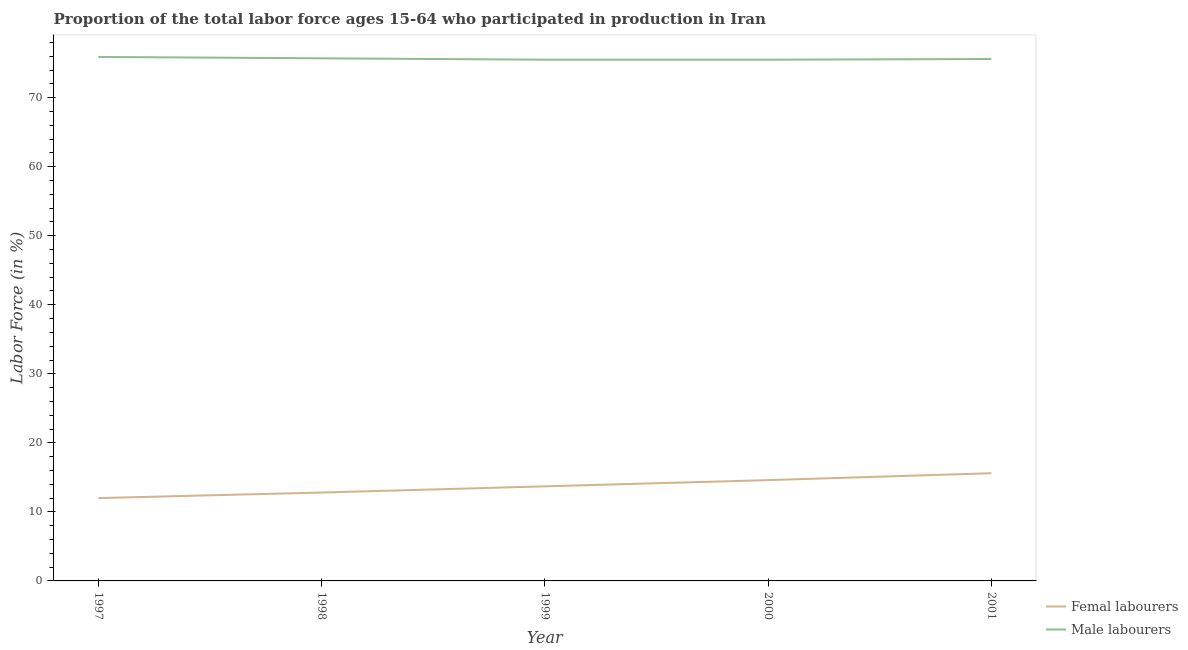How many different coloured lines are there?
Your answer should be compact. 2. What is the percentage of female labor force in 2001?
Keep it short and to the point. 15.6. Across all years, what is the maximum percentage of male labour force?
Your response must be concise. 75.9. Across all years, what is the minimum percentage of female labor force?
Give a very brief answer. 12. In which year was the percentage of male labour force minimum?
Provide a short and direct response. 1999. What is the total percentage of female labor force in the graph?
Make the answer very short. 68.7. What is the difference between the percentage of female labor force in 1998 and that in 2001?
Keep it short and to the point. -2.8. What is the difference between the percentage of male labour force in 1999 and the percentage of female labor force in 1998?
Your answer should be compact. 62.7. What is the average percentage of female labor force per year?
Your answer should be very brief. 13.74. In the year 2001, what is the difference between the percentage of female labor force and percentage of male labour force?
Provide a short and direct response. -60. What is the ratio of the percentage of male labour force in 1997 to that in 2000?
Provide a short and direct response. 1.01. What is the difference between the highest and the lowest percentage of male labour force?
Provide a short and direct response. 0.4. In how many years, is the percentage of female labor force greater than the average percentage of female labor force taken over all years?
Offer a terse response. 2. Is the sum of the percentage of female labor force in 1997 and 1998 greater than the maximum percentage of male labour force across all years?
Offer a very short reply. No. Does the percentage of female labor force monotonically increase over the years?
Provide a short and direct response. Yes. Is the percentage of female labor force strictly greater than the percentage of male labour force over the years?
Offer a terse response. No. How many lines are there?
Offer a very short reply. 2. How many legend labels are there?
Ensure brevity in your answer.  2. What is the title of the graph?
Provide a short and direct response. Proportion of the total labor force ages 15-64 who participated in production in Iran. What is the label or title of the Y-axis?
Offer a very short reply. Labor Force (in %). What is the Labor Force (in %) in Male labourers in 1997?
Ensure brevity in your answer.  75.9. What is the Labor Force (in %) in Femal labourers in 1998?
Your answer should be compact. 12.8. What is the Labor Force (in %) of Male labourers in 1998?
Offer a very short reply. 75.7. What is the Labor Force (in %) of Femal labourers in 1999?
Keep it short and to the point. 13.7. What is the Labor Force (in %) of Male labourers in 1999?
Offer a terse response. 75.5. What is the Labor Force (in %) of Femal labourers in 2000?
Your answer should be compact. 14.6. What is the Labor Force (in %) in Male labourers in 2000?
Provide a short and direct response. 75.5. What is the Labor Force (in %) of Femal labourers in 2001?
Keep it short and to the point. 15.6. What is the Labor Force (in %) in Male labourers in 2001?
Offer a terse response. 75.6. Across all years, what is the maximum Labor Force (in %) of Femal labourers?
Provide a short and direct response. 15.6. Across all years, what is the maximum Labor Force (in %) of Male labourers?
Make the answer very short. 75.9. Across all years, what is the minimum Labor Force (in %) of Femal labourers?
Make the answer very short. 12. Across all years, what is the minimum Labor Force (in %) of Male labourers?
Provide a succinct answer. 75.5. What is the total Labor Force (in %) in Femal labourers in the graph?
Keep it short and to the point. 68.7. What is the total Labor Force (in %) of Male labourers in the graph?
Your answer should be very brief. 378.2. What is the difference between the Labor Force (in %) in Male labourers in 1997 and that in 1998?
Your response must be concise. 0.2. What is the difference between the Labor Force (in %) of Femal labourers in 1997 and that in 1999?
Offer a terse response. -1.7. What is the difference between the Labor Force (in %) of Male labourers in 1997 and that in 2001?
Your response must be concise. 0.3. What is the difference between the Labor Force (in %) in Femal labourers in 1998 and that in 2001?
Keep it short and to the point. -2.8. What is the difference between the Labor Force (in %) in Male labourers in 1998 and that in 2001?
Give a very brief answer. 0.1. What is the difference between the Labor Force (in %) of Femal labourers in 1999 and that in 2000?
Keep it short and to the point. -0.9. What is the difference between the Labor Force (in %) of Femal labourers in 1997 and the Labor Force (in %) of Male labourers in 1998?
Give a very brief answer. -63.7. What is the difference between the Labor Force (in %) of Femal labourers in 1997 and the Labor Force (in %) of Male labourers in 1999?
Your answer should be very brief. -63.5. What is the difference between the Labor Force (in %) in Femal labourers in 1997 and the Labor Force (in %) in Male labourers in 2000?
Offer a terse response. -63.5. What is the difference between the Labor Force (in %) of Femal labourers in 1997 and the Labor Force (in %) of Male labourers in 2001?
Provide a succinct answer. -63.6. What is the difference between the Labor Force (in %) of Femal labourers in 1998 and the Labor Force (in %) of Male labourers in 1999?
Keep it short and to the point. -62.7. What is the difference between the Labor Force (in %) in Femal labourers in 1998 and the Labor Force (in %) in Male labourers in 2000?
Your answer should be compact. -62.7. What is the difference between the Labor Force (in %) of Femal labourers in 1998 and the Labor Force (in %) of Male labourers in 2001?
Provide a short and direct response. -62.8. What is the difference between the Labor Force (in %) in Femal labourers in 1999 and the Labor Force (in %) in Male labourers in 2000?
Your answer should be compact. -61.8. What is the difference between the Labor Force (in %) in Femal labourers in 1999 and the Labor Force (in %) in Male labourers in 2001?
Your response must be concise. -61.9. What is the difference between the Labor Force (in %) of Femal labourers in 2000 and the Labor Force (in %) of Male labourers in 2001?
Provide a succinct answer. -61. What is the average Labor Force (in %) of Femal labourers per year?
Ensure brevity in your answer.  13.74. What is the average Labor Force (in %) in Male labourers per year?
Offer a terse response. 75.64. In the year 1997, what is the difference between the Labor Force (in %) in Femal labourers and Labor Force (in %) in Male labourers?
Offer a very short reply. -63.9. In the year 1998, what is the difference between the Labor Force (in %) of Femal labourers and Labor Force (in %) of Male labourers?
Make the answer very short. -62.9. In the year 1999, what is the difference between the Labor Force (in %) in Femal labourers and Labor Force (in %) in Male labourers?
Provide a succinct answer. -61.8. In the year 2000, what is the difference between the Labor Force (in %) in Femal labourers and Labor Force (in %) in Male labourers?
Keep it short and to the point. -60.9. In the year 2001, what is the difference between the Labor Force (in %) of Femal labourers and Labor Force (in %) of Male labourers?
Your response must be concise. -60. What is the ratio of the Labor Force (in %) of Male labourers in 1997 to that in 1998?
Offer a terse response. 1. What is the ratio of the Labor Force (in %) in Femal labourers in 1997 to that in 1999?
Keep it short and to the point. 0.88. What is the ratio of the Labor Force (in %) in Male labourers in 1997 to that in 1999?
Your response must be concise. 1.01. What is the ratio of the Labor Force (in %) of Femal labourers in 1997 to that in 2000?
Your answer should be compact. 0.82. What is the ratio of the Labor Force (in %) in Femal labourers in 1997 to that in 2001?
Offer a terse response. 0.77. What is the ratio of the Labor Force (in %) in Male labourers in 1997 to that in 2001?
Your response must be concise. 1. What is the ratio of the Labor Force (in %) in Femal labourers in 1998 to that in 1999?
Give a very brief answer. 0.93. What is the ratio of the Labor Force (in %) in Femal labourers in 1998 to that in 2000?
Make the answer very short. 0.88. What is the ratio of the Labor Force (in %) of Femal labourers in 1998 to that in 2001?
Provide a short and direct response. 0.82. What is the ratio of the Labor Force (in %) of Femal labourers in 1999 to that in 2000?
Your answer should be compact. 0.94. What is the ratio of the Labor Force (in %) in Femal labourers in 1999 to that in 2001?
Keep it short and to the point. 0.88. What is the ratio of the Labor Force (in %) of Femal labourers in 2000 to that in 2001?
Offer a very short reply. 0.94. What is the difference between the highest and the second highest Labor Force (in %) of Femal labourers?
Keep it short and to the point. 1. What is the difference between the highest and the lowest Labor Force (in %) of Male labourers?
Give a very brief answer. 0.4. 